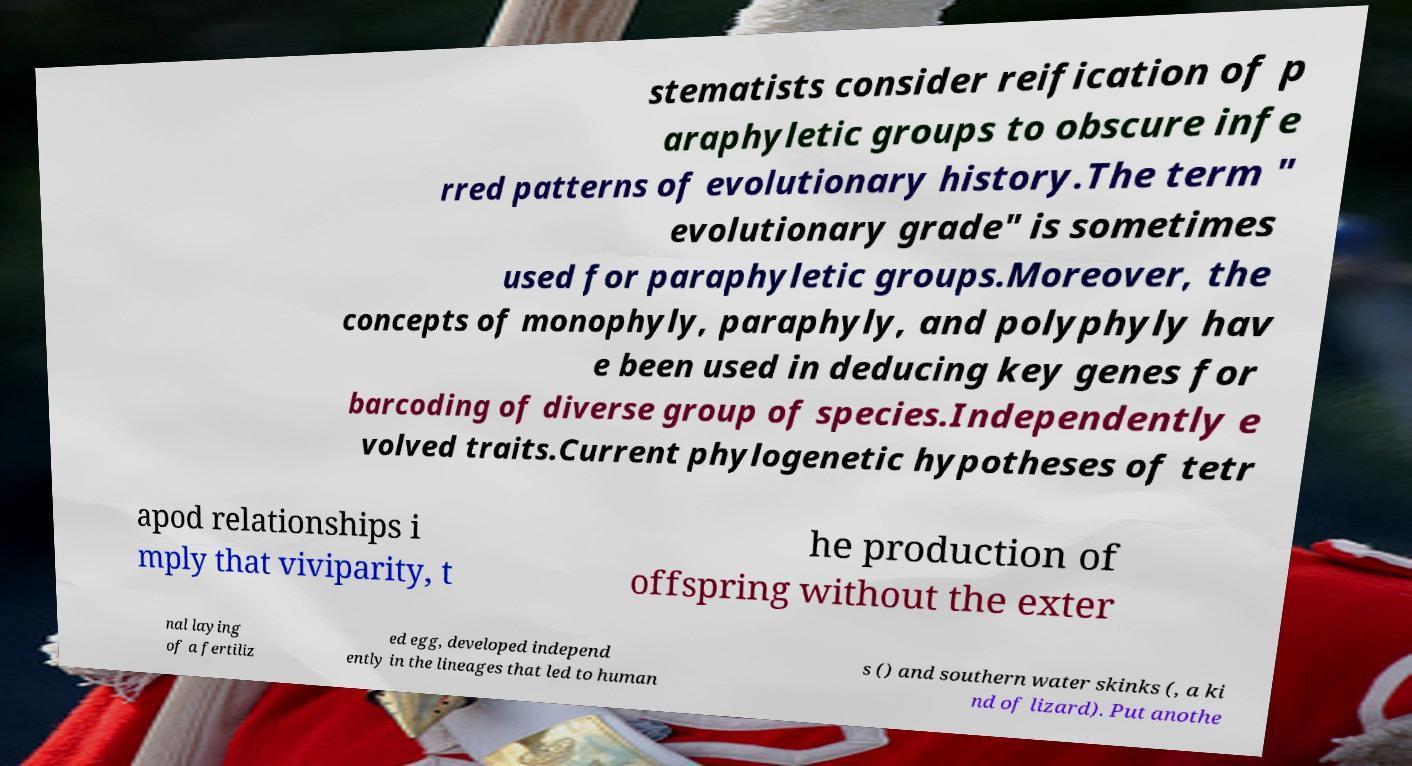Can you read and provide the text displayed in the image?This photo seems to have some interesting text. Can you extract and type it out for me? stematists consider reification of p araphyletic groups to obscure infe rred patterns of evolutionary history.The term " evolutionary grade" is sometimes used for paraphyletic groups.Moreover, the concepts of monophyly, paraphyly, and polyphyly hav e been used in deducing key genes for barcoding of diverse group of species.Independently e volved traits.Current phylogenetic hypotheses of tetr apod relationships i mply that viviparity, t he production of offspring without the exter nal laying of a fertiliz ed egg, developed independ ently in the lineages that led to human s () and southern water skinks (, a ki nd of lizard). Put anothe 